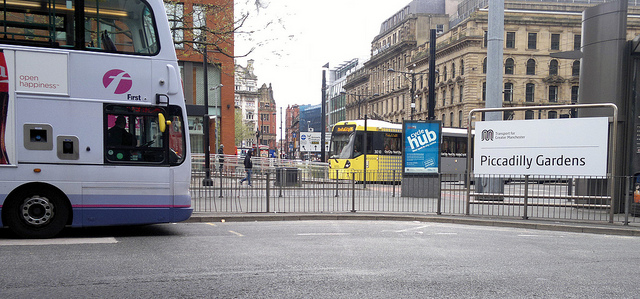Identify the text contained in this image. Open happiness First Gardens Piccadilly hub f 